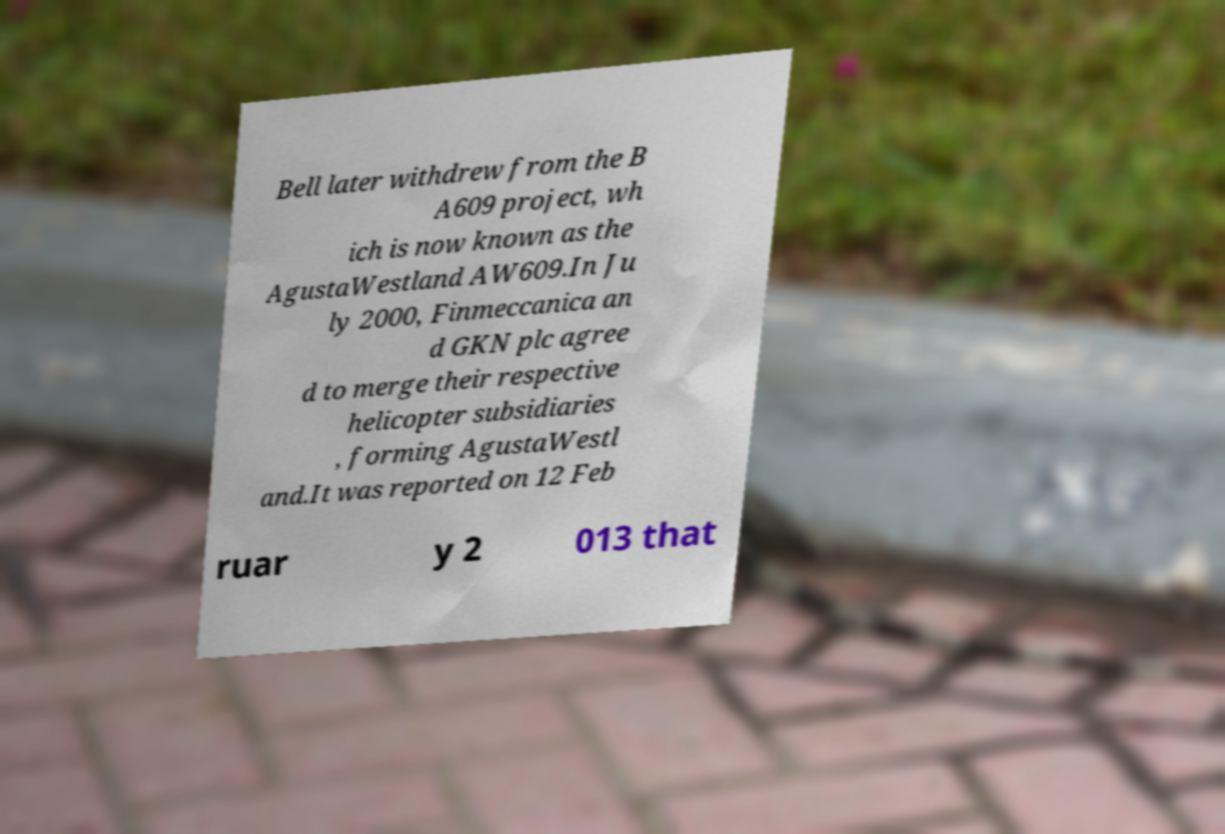Could you extract and type out the text from this image? Bell later withdrew from the B A609 project, wh ich is now known as the AgustaWestland AW609.In Ju ly 2000, Finmeccanica an d GKN plc agree d to merge their respective helicopter subsidiaries , forming AgustaWestl and.It was reported on 12 Feb ruar y 2 013 that 